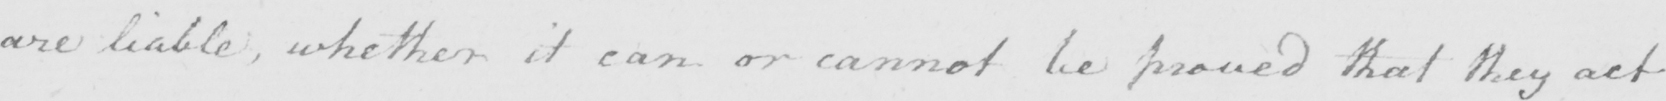What text is written in this handwritten line? are liable, whether it can or cannot be proved that they act 